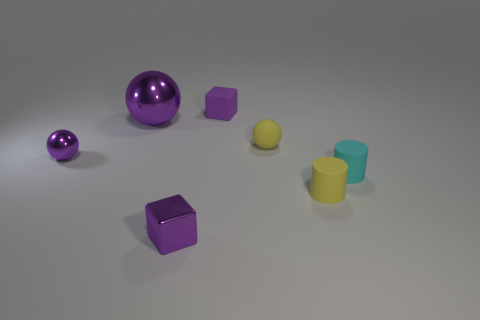What number of things are either purple metallic balls that are left of the cyan matte thing or blocks in front of the small purple rubber cube?
Your response must be concise. 3. What number of other things are there of the same color as the tiny shiny block?
Make the answer very short. 3. Is the number of blocks behind the small rubber sphere less than the number of tiny rubber balls to the left of the large shiny object?
Keep it short and to the point. No. How many objects are there?
Provide a succinct answer. 7. Are there any other things that are the same material as the small yellow ball?
Keep it short and to the point. Yes. What is the material of the other purple object that is the same shape as the large purple shiny thing?
Offer a terse response. Metal. Is the number of big purple metallic objects that are in front of the cyan cylinder less than the number of big purple shiny things?
Give a very brief answer. Yes. There is a large object behind the yellow sphere; does it have the same shape as the cyan object?
Offer a very short reply. No. Is there any other thing of the same color as the big metallic object?
Offer a very short reply. Yes. The purple block that is made of the same material as the yellow cylinder is what size?
Provide a succinct answer. Small. 